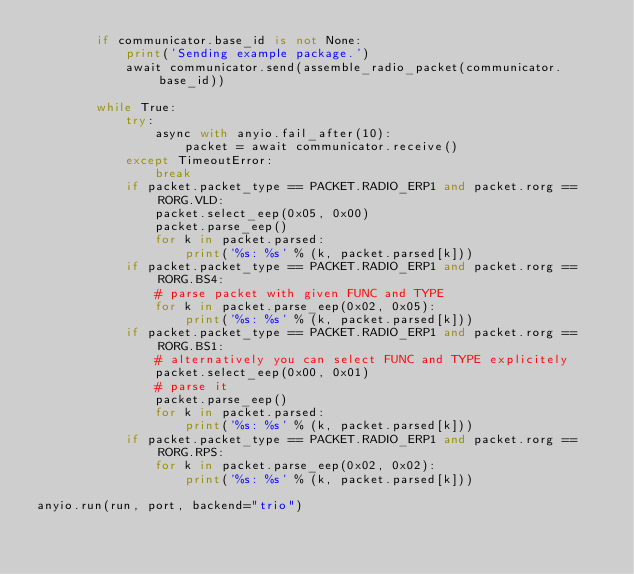Convert code to text. <code><loc_0><loc_0><loc_500><loc_500><_Python_>        if communicator.base_id is not None:
            print('Sending example package.')
            await communicator.send(assemble_radio_packet(communicator.base_id))

        while True:
            try:
                async with anyio.fail_after(10):
                    packet = await communicator.receive()
            except TimeoutError:
                break
            if packet.packet_type == PACKET.RADIO_ERP1 and packet.rorg == RORG.VLD:
                packet.select_eep(0x05, 0x00)
                packet.parse_eep()
                for k in packet.parsed:
                    print('%s: %s' % (k, packet.parsed[k]))
            if packet.packet_type == PACKET.RADIO_ERP1 and packet.rorg == RORG.BS4:
                # parse packet with given FUNC and TYPE
                for k in packet.parse_eep(0x02, 0x05):
                    print('%s: %s' % (k, packet.parsed[k]))
            if packet.packet_type == PACKET.RADIO_ERP1 and packet.rorg == RORG.BS1:
                # alternatively you can select FUNC and TYPE explicitely
                packet.select_eep(0x00, 0x01)
                # parse it
                packet.parse_eep()
                for k in packet.parsed:
                    print('%s: %s' % (k, packet.parsed[k]))
            if packet.packet_type == PACKET.RADIO_ERP1 and packet.rorg == RORG.RPS:
                for k in packet.parse_eep(0x02, 0x02):
                    print('%s: %s' % (k, packet.parsed[k]))

anyio.run(run, port, backend="trio")
</code> 